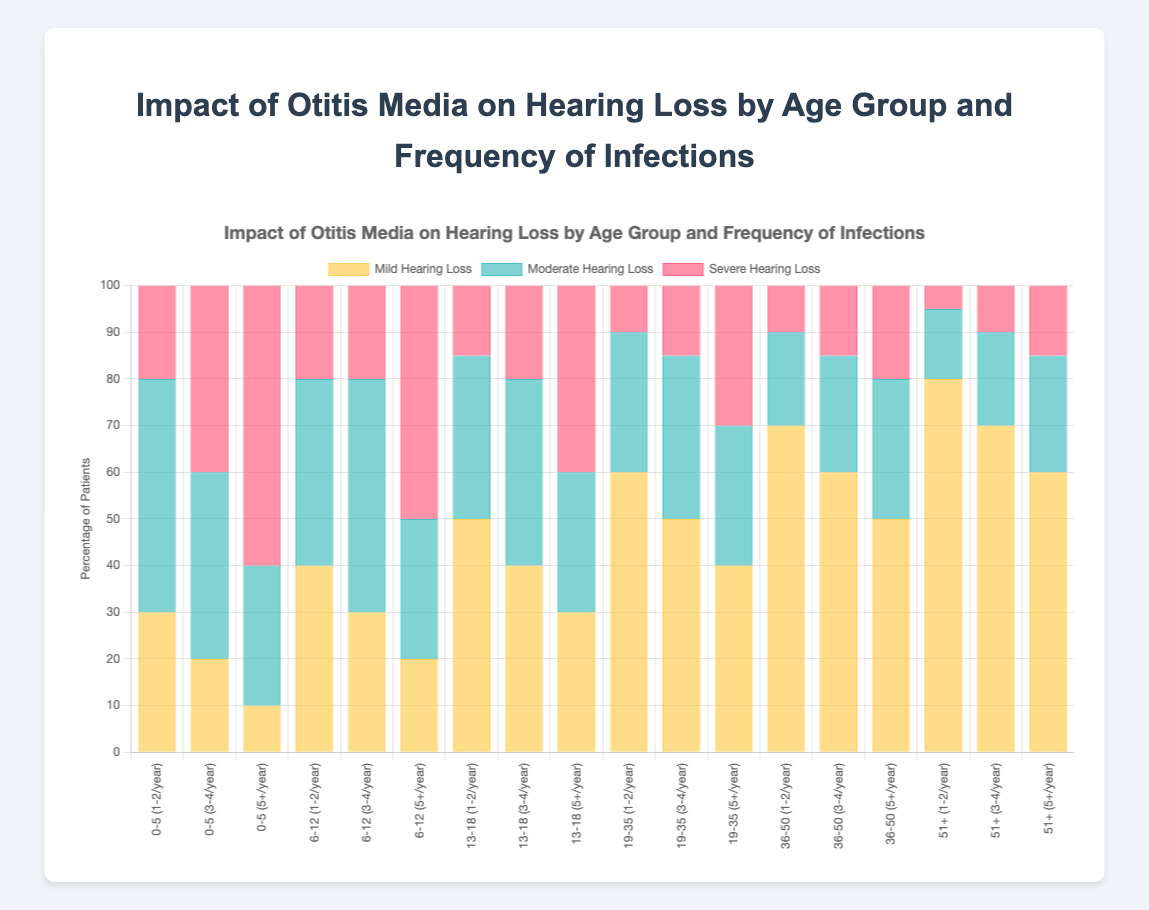What is the percentage of patients aged 0-5 with severe hearing loss who have infections 5 or more times per year? To find the percentage of patients aged 0-5 with severe hearing loss and 5+ infections per year, look at the "0-5" age group with the "5+/year" frequency. The severe hearing loss percentage is 60%.
Answer: 60% Which age group has the highest percentage of mild hearing loss for those with 1-2 infections per year? Compare all the mild hearing loss percentages across age groups for the "1-2/year" frequency category. The "51+" age group has a mild hearing loss percentage of 80%, which is the highest.
Answer: 51+ How does the percentage of moderate hearing loss compare between the age groups 6-12 and 19-35 for those with 1-2 infections per year? For the "1-2/year" frequency, the 6-12 age group has 40% moderate hearing loss, while the 19-35 age group has 30%. 40% is greater than 30%.
Answer: 40% > 30% Which age group with 3-4 infections per year shows the least percentage of severe hearing loss? Compare the severe hearing loss percentages for the "3-4/year" frequency across all age groups. The "51+" age group has the least severe hearing loss with 10%.
Answer: 51+ What is the total percentage of patients aged 0-5 with any degree of hearing loss who have 1-2 infections per year? Sum the percentages of mild, moderate, and severe hearing loss for the "0-5" age group with "1-2/year" frequency. 30 (mild) + 50 (moderate) + 20 (severe) equals 100%.
Answer: 100% Is the percentage of moderate hearing loss higher for the 13-18 age group with 3-4 infections per year or the 36-50 age group with 5+ infections per year? Compare the percentages: 13-18 with "3-4/year" has 40%, and 36-50 with "5+/year" has 30%. Therefore, 40% is higher than 30%.
Answer: 40% > 30% What percentage of patients aged 19-35 with 5+ infections per year have moderate or severe hearing loss combined? Add the moderate (30%) and severe (30%) hearing loss percentages for the "19-35" age group with "5+/year" frequency. 30% + 30% equals 60%.
Answer: 60% In the 6-12 age group, how much more common is mild hearing loss for those with 1-2 infections per year compared to those with 5+ infections per year? Subtract the mild hearing loss percentage of the "5+/year" frequency (20%) from that of the "1-2/year" frequency (40%). 40% - 20% equals 20%.
Answer: 20% Which age group has the lowest percentage of severe hearing loss for 1-2 infections per year? Compare the severe hearing loss percentages for "1-2/year" frequency across all age groups. The "51+" age group has the lowest severe hearing loss with 5%.
Answer: 51+ 